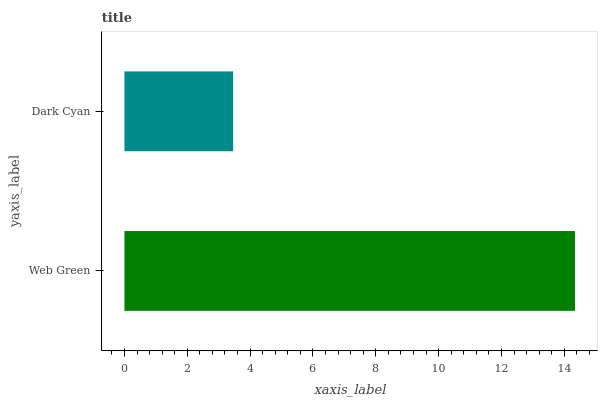Is Dark Cyan the minimum?
Answer yes or no. Yes. Is Web Green the maximum?
Answer yes or no. Yes. Is Dark Cyan the maximum?
Answer yes or no. No. Is Web Green greater than Dark Cyan?
Answer yes or no. Yes. Is Dark Cyan less than Web Green?
Answer yes or no. Yes. Is Dark Cyan greater than Web Green?
Answer yes or no. No. Is Web Green less than Dark Cyan?
Answer yes or no. No. Is Web Green the high median?
Answer yes or no. Yes. Is Dark Cyan the low median?
Answer yes or no. Yes. Is Dark Cyan the high median?
Answer yes or no. No. Is Web Green the low median?
Answer yes or no. No. 